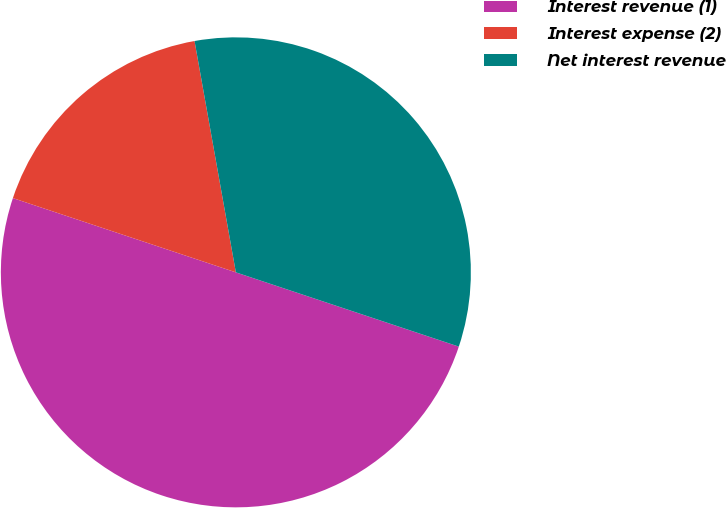<chart> <loc_0><loc_0><loc_500><loc_500><pie_chart><fcel>Interest revenue (1)<fcel>Interest expense (2)<fcel>Net interest revenue<nl><fcel>50.0%<fcel>17.07%<fcel>32.93%<nl></chart> 